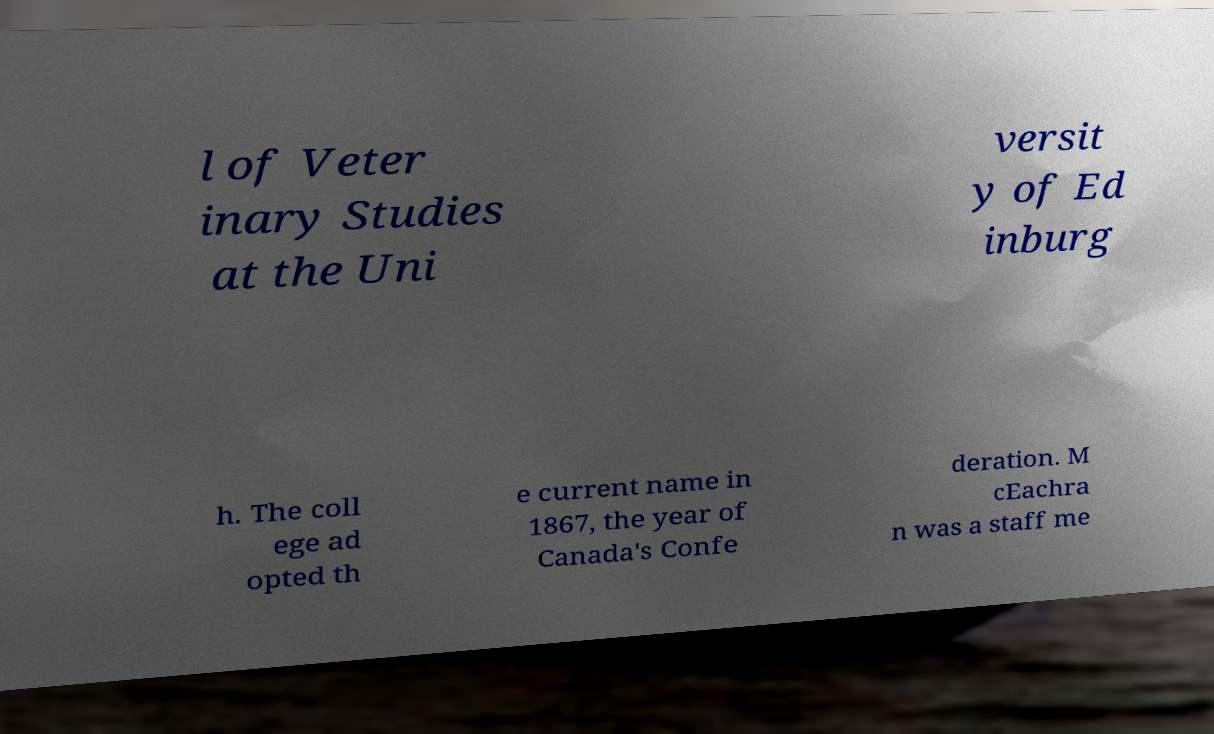Could you assist in decoding the text presented in this image and type it out clearly? l of Veter inary Studies at the Uni versit y of Ed inburg h. The coll ege ad opted th e current name in 1867, the year of Canada's Confe deration. M cEachra n was a staff me 